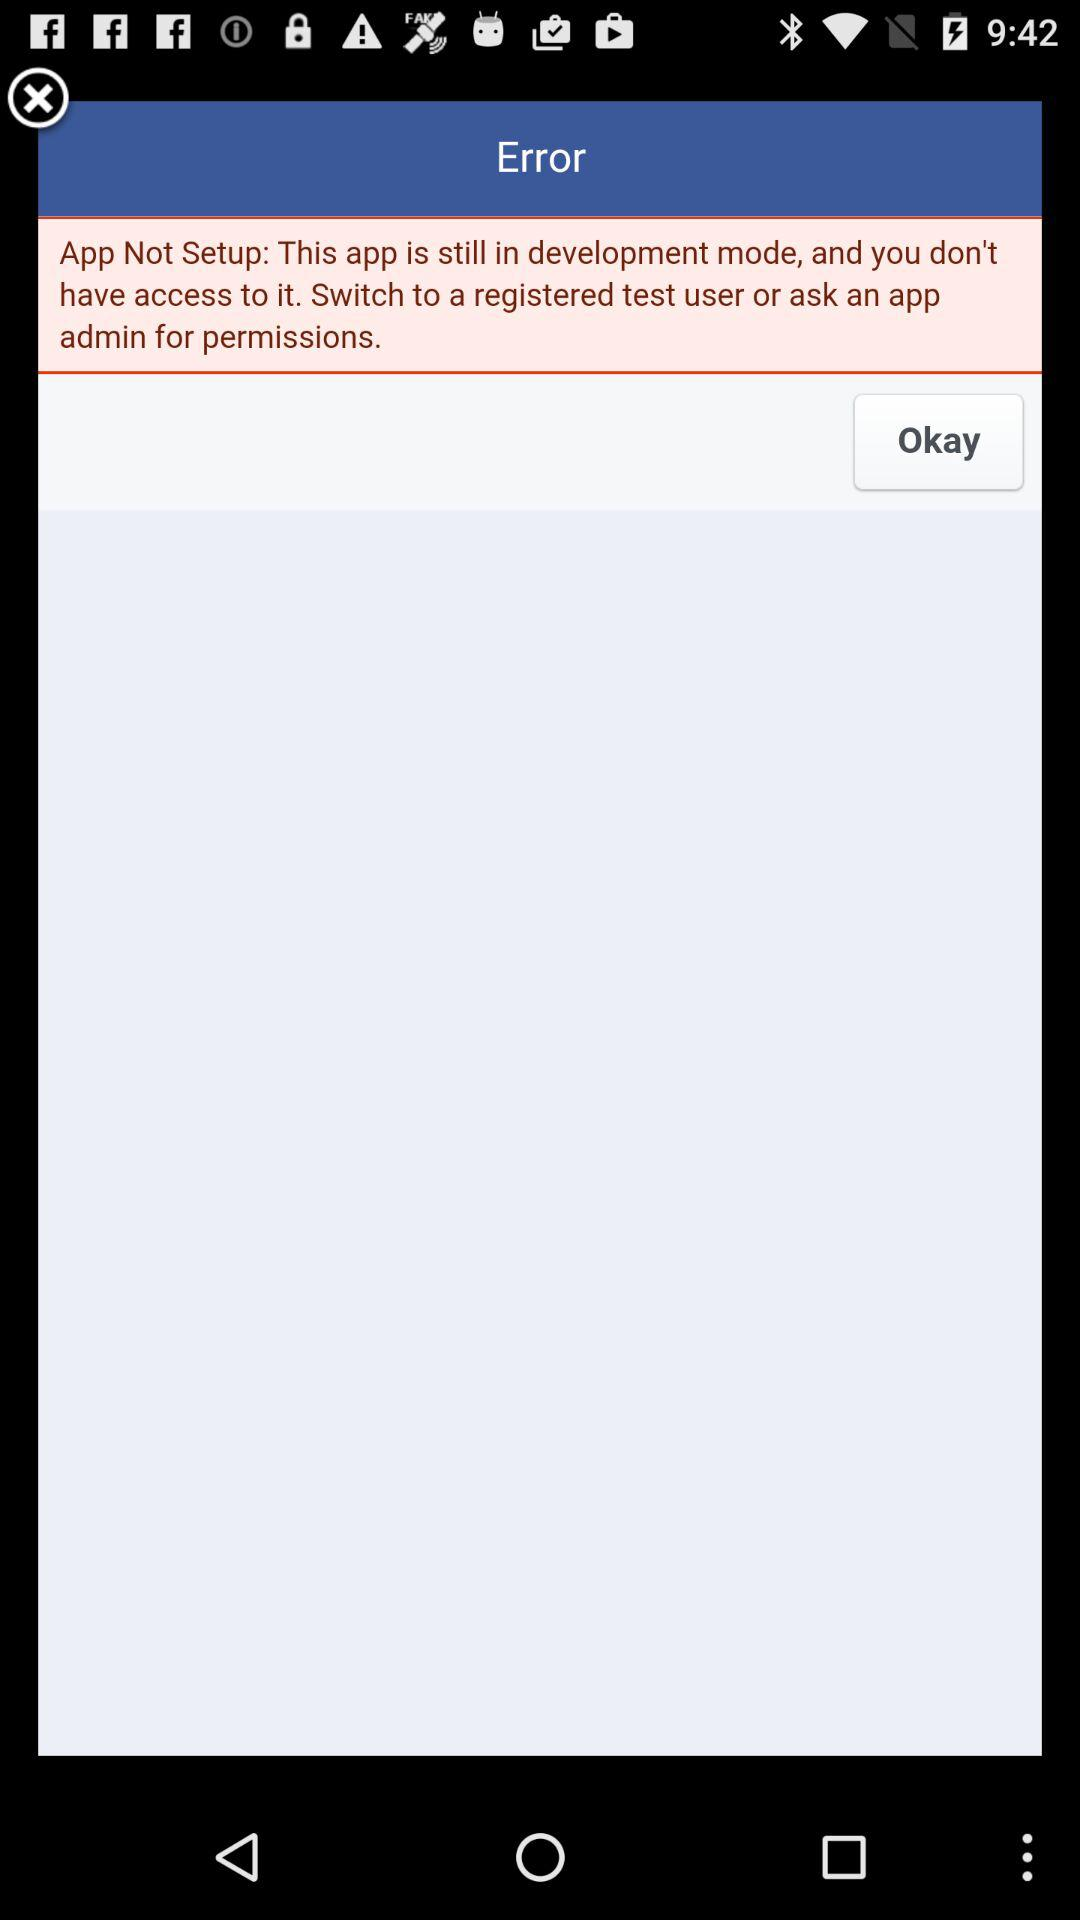What is the displayed error message? The displayed error message is "App Not Setup: This app is still in development mode, and you don't have access to it. Switch to a registered test user or ask an app admin for permissions.". 